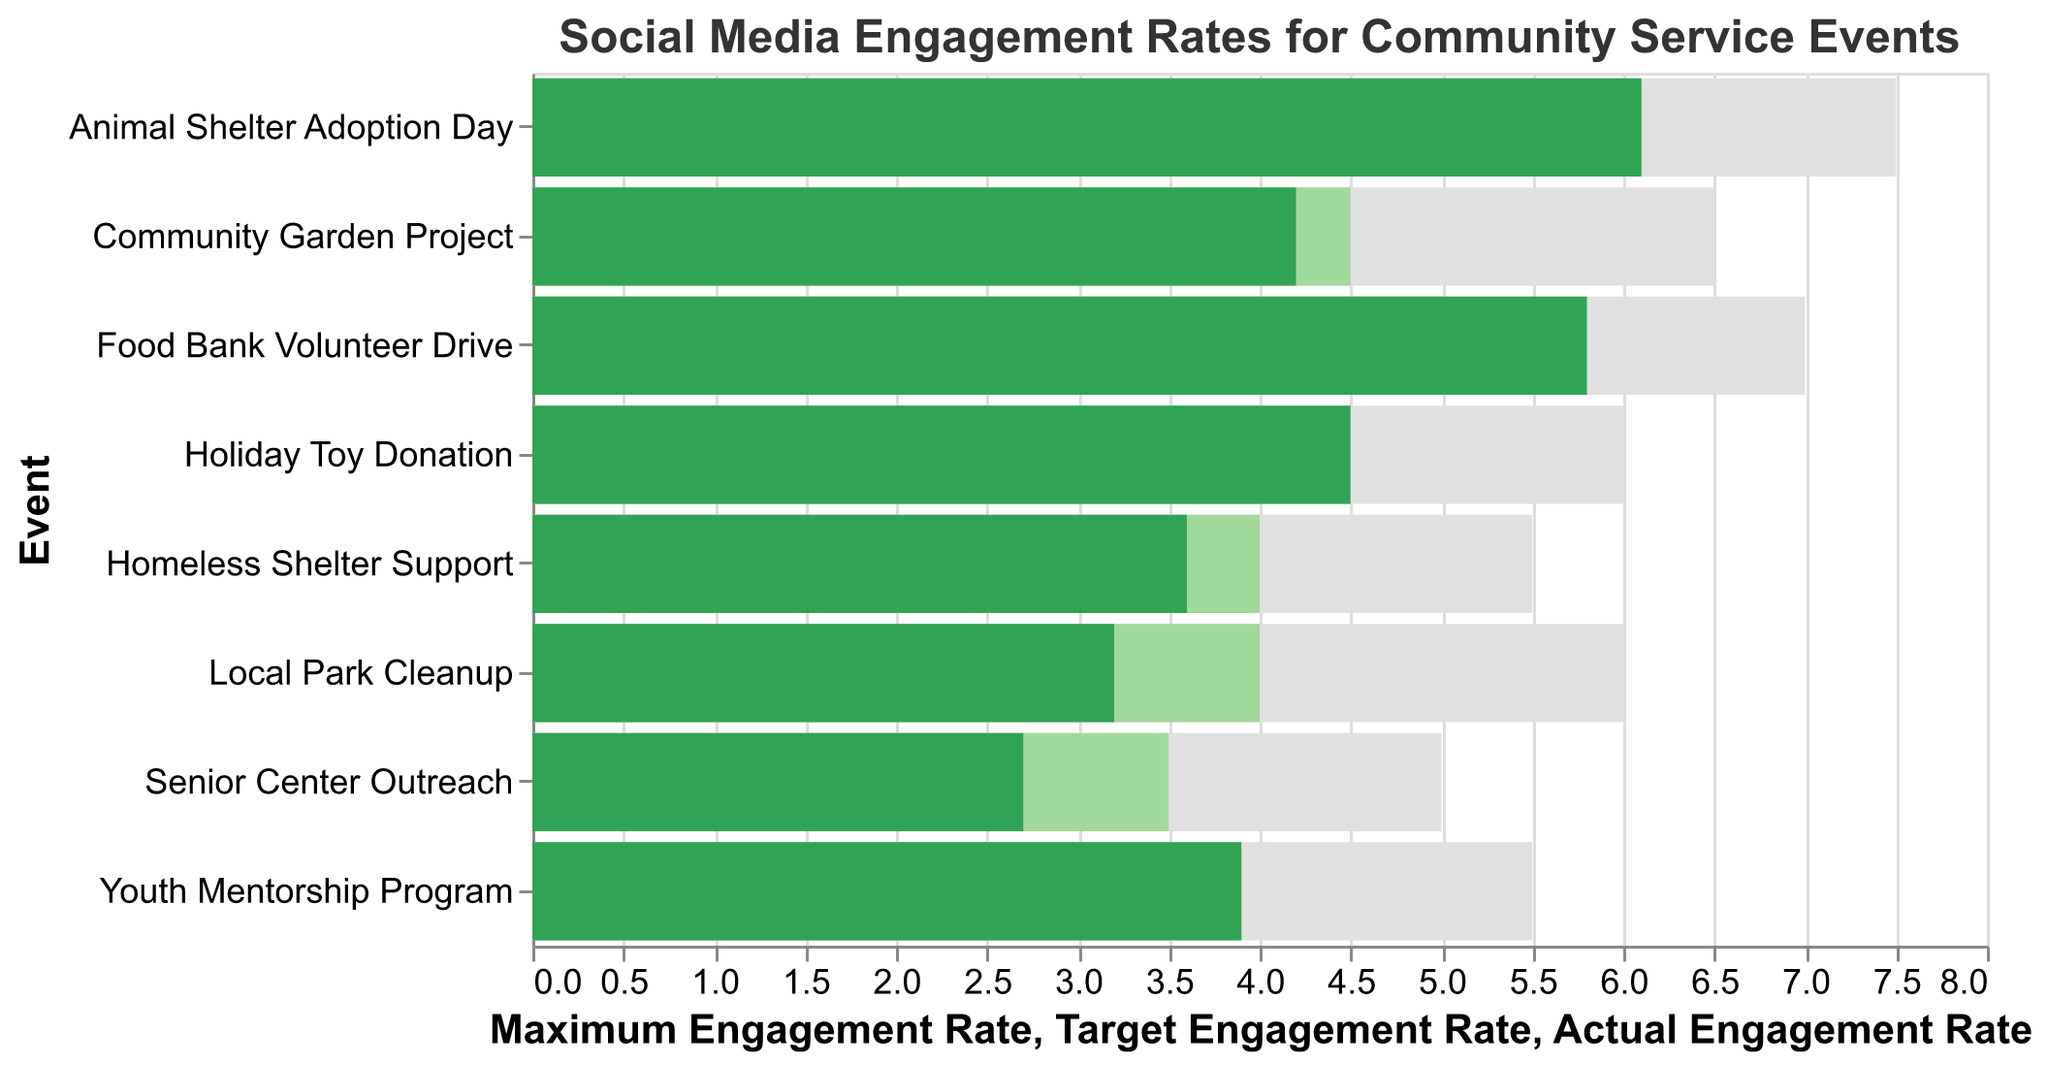What is the title of the chart? The title of the chart is positioned at the top and indicates what the chart represents. It reads, "Social Media Engagement Rates for Community Service Events".
Answer: Social Media Engagement Rates for Community Service Events Which event has the highest actual engagement rate? By looking at the "Actual Engagement Rate" bars, the longest bar indicates the highest value, which is for "Animal Shelter Adoption Day".
Answer: Animal Shelter Adoption Day For the "Local Park Cleanup" event, is the actual engagement rate above or below the target engagement rate? We compare the lengths of the "Actual Engagement Rate" and "Target Engagement Rate" bars for the "Local Park Cleanup" event. The "Actual Engagement Rate" is shorter, indicating it is below the target.
Answer: Below What is the difference between the actual and maximum engagement rates for the "Food Bank Volunteer Drive"? Subtract the actual engagement rate (5.8) from the maximum engagement rate (7.0) for the "Food Bank Volunteer Drive". The difference is 7.0 - 5.8 = 1.2.
Answer: 1.2 Which event exceeded its target engagement rate by the largest margin? We need to identify the event where the "Actual Engagement Rate" bar is most significantly longer than the "Target Engagement Rate" bar. "Animal Shelter Adoption Day" shows the largest margin of actual engagement rate (6.1) over target (5.5).
Answer: Animal Shelter Adoption Day How many events have an actual engagement rate that meets or exceeds the target engagement rate? By counting the bars where the "Actual Engagement Rate" is equal to or longer than the "Target Engagement Rate", we find: "Food Bank Volunteer Drive," "Holiday Toy Donation," "Youth Mentorship Program," and "Animal Shelter Adoption Day."
Answer: 4 For the "Community Garden Project," what is the difference between the target and maximum engagement rates? Subtract the target engagement rate (4.5) from the maximum engagement rate (6.5) for the "Community Garden Project". The difference is 6.5 - 4.5 = 2.0.
Answer: 2.0 Which events failed to meet their target engagement rates? By visually checking each event, we see that the "Actual Engagement Rate" bars for "Local Park Cleanup," "Senior Center Outreach," "Community Garden Project," and "Homeless Shelter Support" are shorter than their respective "Target Engagement Rate" bars.
Answer: Local Park Cleanup, Senior Center Outreach, Community Garden Project, Homeless Shelter Support 